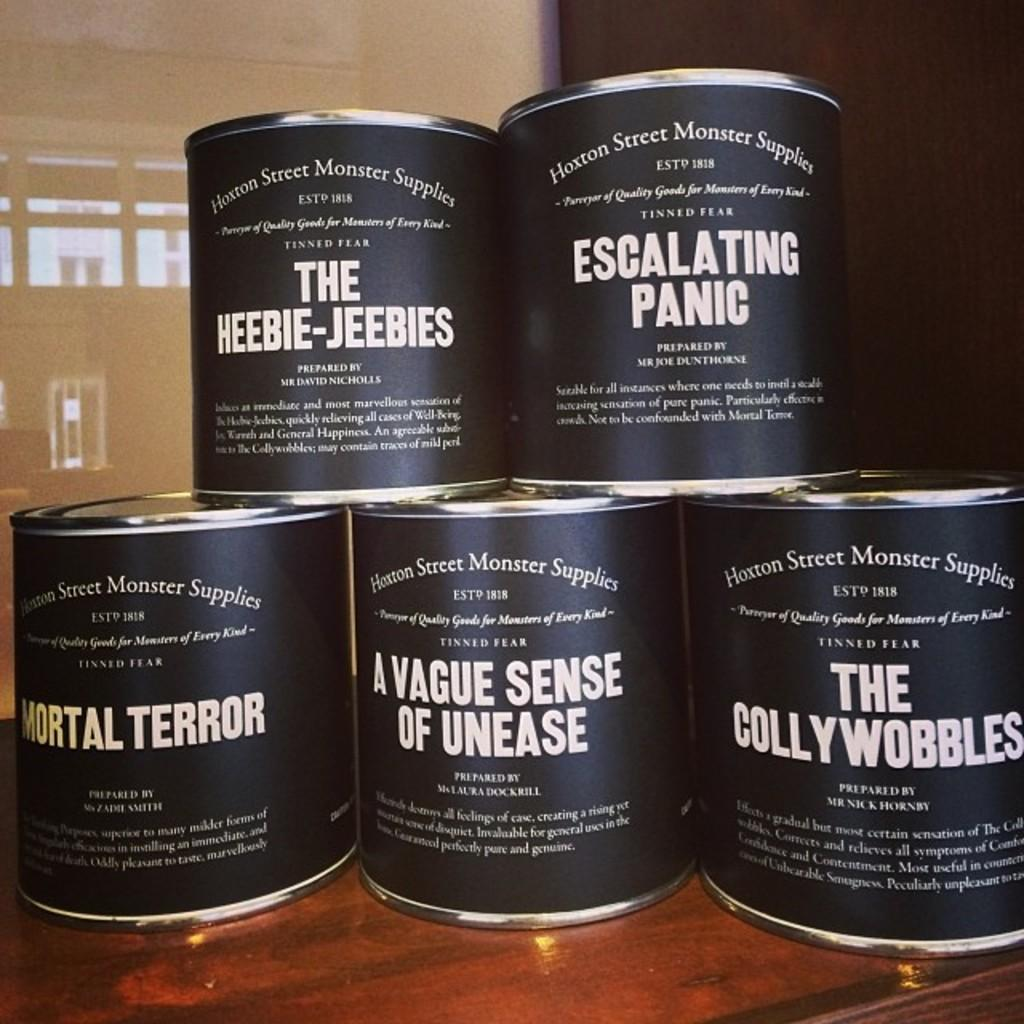Provide a one-sentence caption for the provided image. Five cans with humorous labels like Mortal Terror and Escalating Panic are stacked on a table. 